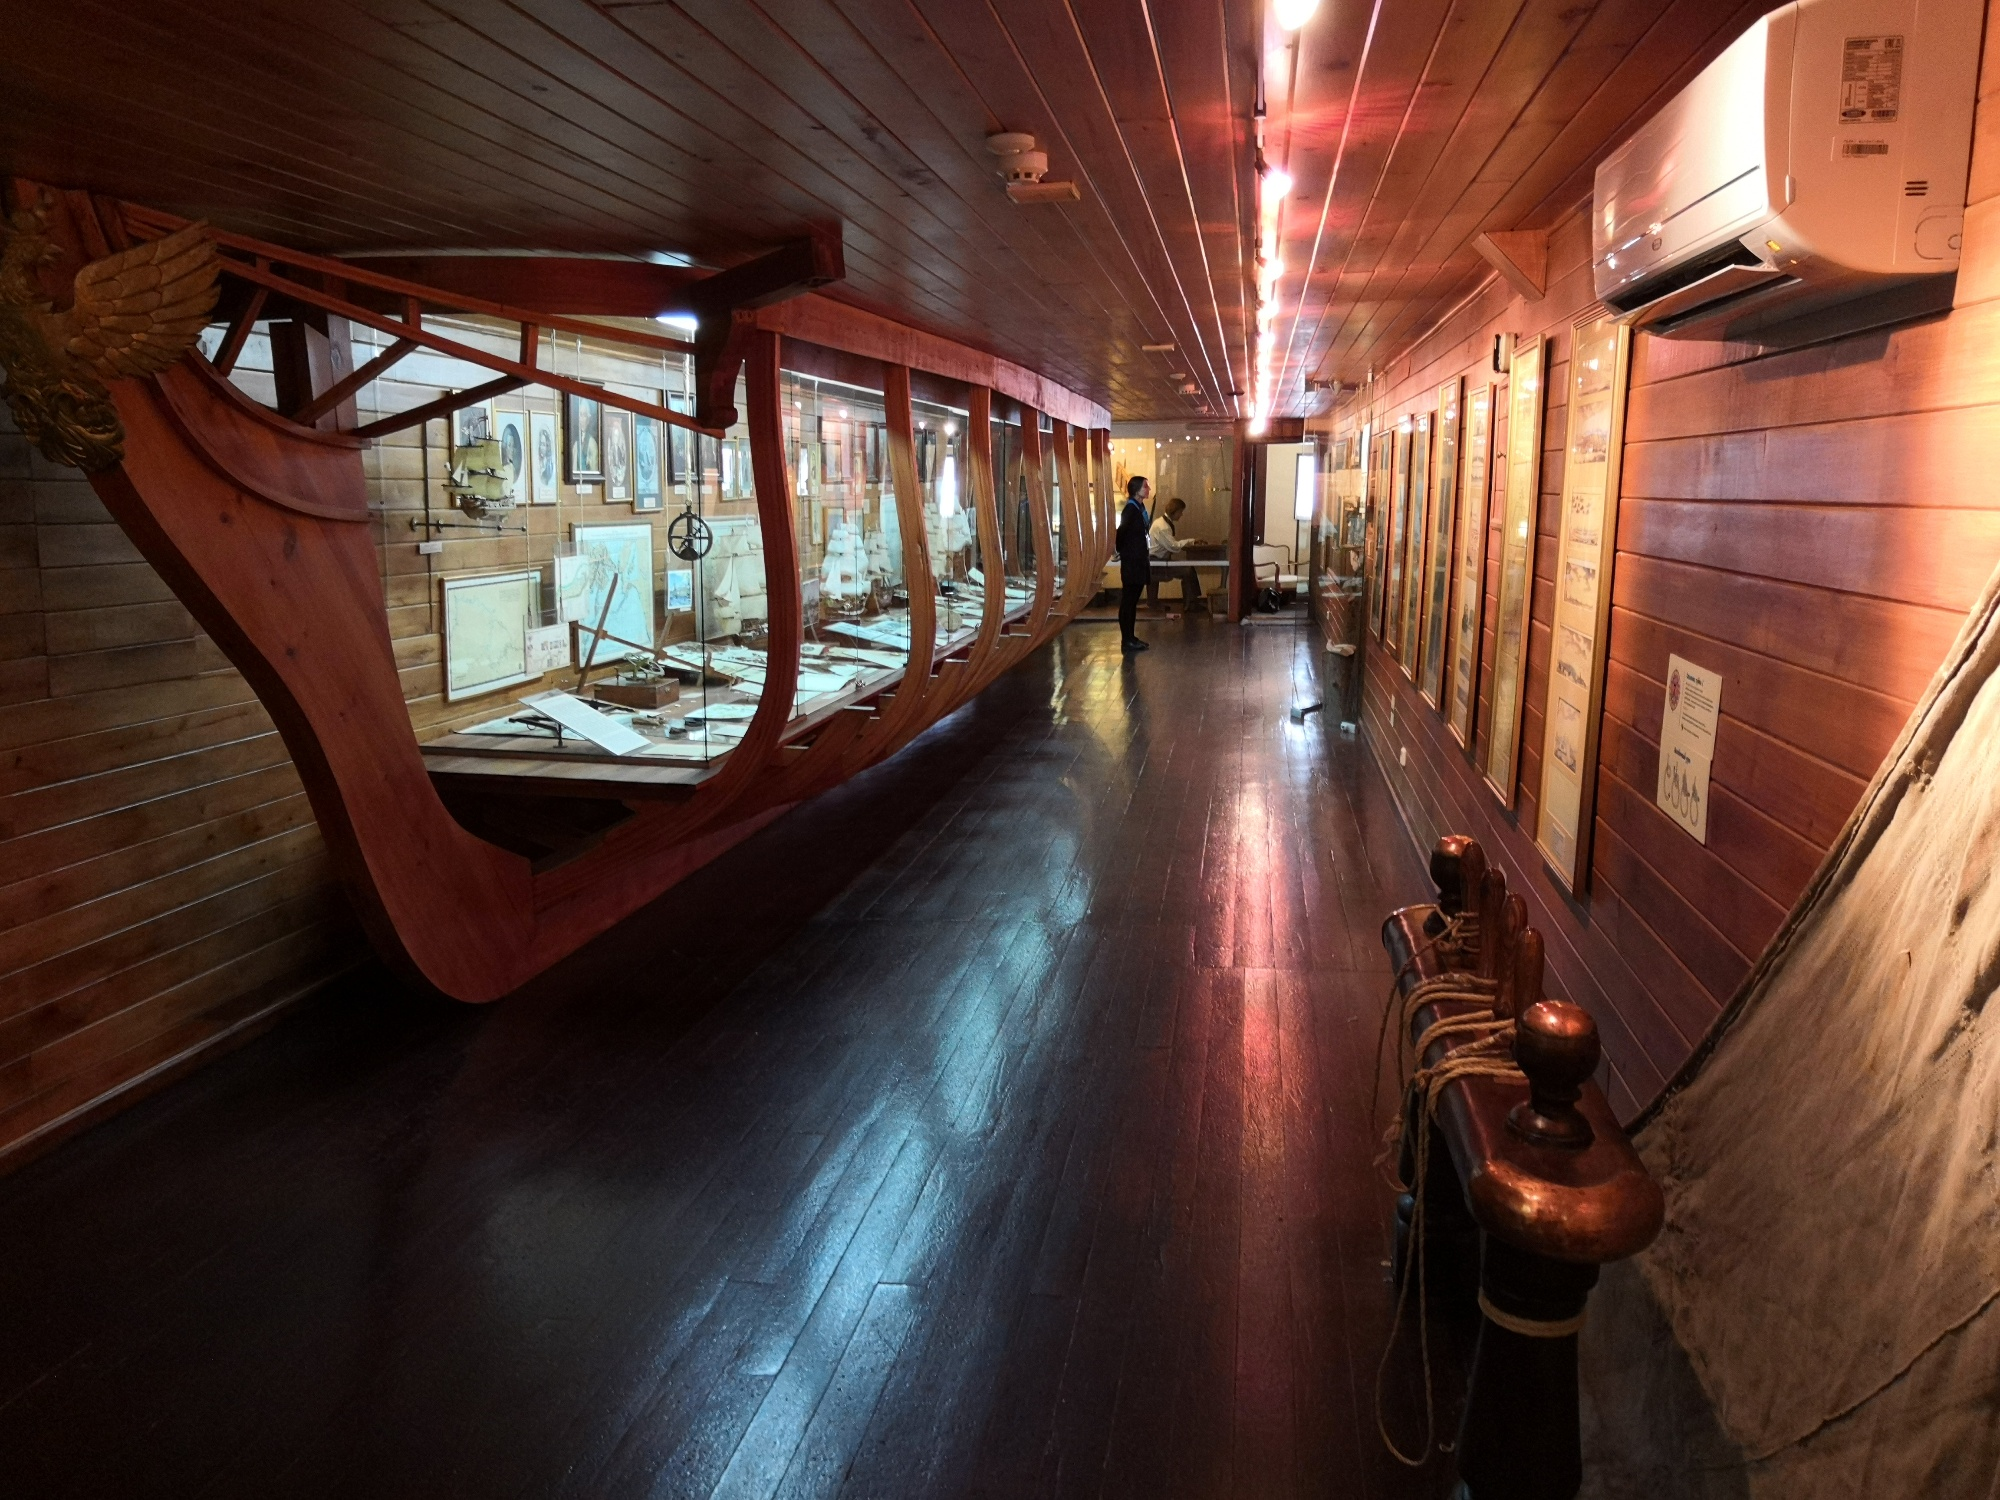Can you explain the significance of the artifacts displayed here? The artifacts displayed in this exhibit are significant as they provide a tangible connection to the era of early maritime exploration. Many of the items likely include navigational instruments such as astrolabes and compasses, which were crucial for seafarers in the 15th century. The maps showcased are probably replicas of those used during Christopher Columbus's voyages, detailing the routes and discoveries that altered the course of history. Additionally, the ship models and tools represent the technology of the time, giving insight into the craftsmanship and maritime knowledge that made those long voyages possible. 